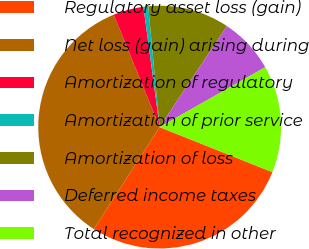Convert chart to OTSL. <chart><loc_0><loc_0><loc_500><loc_500><pie_chart><fcel>Regulatory asset loss (gain)<fcel>Net loss (gain) arising during<fcel>Amortization of regulatory<fcel>Amortization of prior service<fcel>Amortization of loss<fcel>Deferred income taxes<fcel>Total recognized in other<nl><fcel>28.08%<fcel>34.7%<fcel>4.04%<fcel>0.63%<fcel>10.85%<fcel>7.44%<fcel>14.26%<nl></chart> 